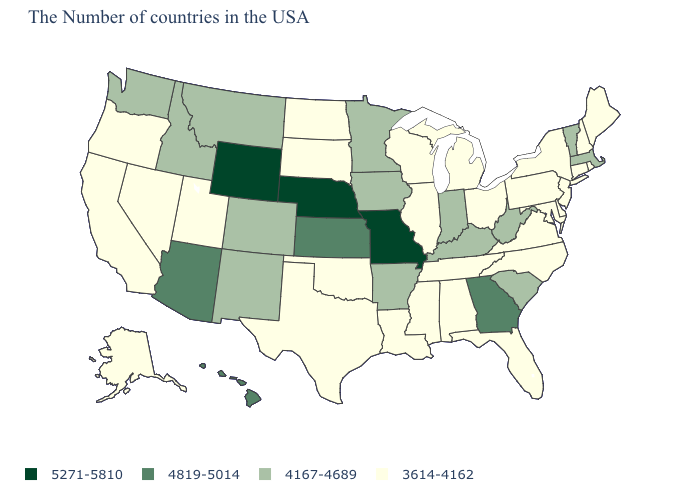How many symbols are there in the legend?
Quick response, please. 4. What is the lowest value in states that border Massachusetts?
Give a very brief answer. 3614-4162. What is the highest value in states that border North Carolina?
Give a very brief answer. 4819-5014. What is the value of North Carolina?
Write a very short answer. 3614-4162. Name the states that have a value in the range 5271-5810?
Quick response, please. Missouri, Nebraska, Wyoming. How many symbols are there in the legend?
Quick response, please. 4. What is the lowest value in the South?
Short answer required. 3614-4162. What is the highest value in states that border Montana?
Keep it brief. 5271-5810. Does the map have missing data?
Write a very short answer. No. What is the value of Illinois?
Short answer required. 3614-4162. Name the states that have a value in the range 4819-5014?
Keep it brief. Georgia, Kansas, Arizona, Hawaii. Does Pennsylvania have the same value as Ohio?
Give a very brief answer. Yes. Name the states that have a value in the range 4167-4689?
Quick response, please. Massachusetts, Vermont, South Carolina, West Virginia, Kentucky, Indiana, Arkansas, Minnesota, Iowa, Colorado, New Mexico, Montana, Idaho, Washington. Name the states that have a value in the range 5271-5810?
Give a very brief answer. Missouri, Nebraska, Wyoming. Does Montana have a lower value than Alaska?
Be succinct. No. 